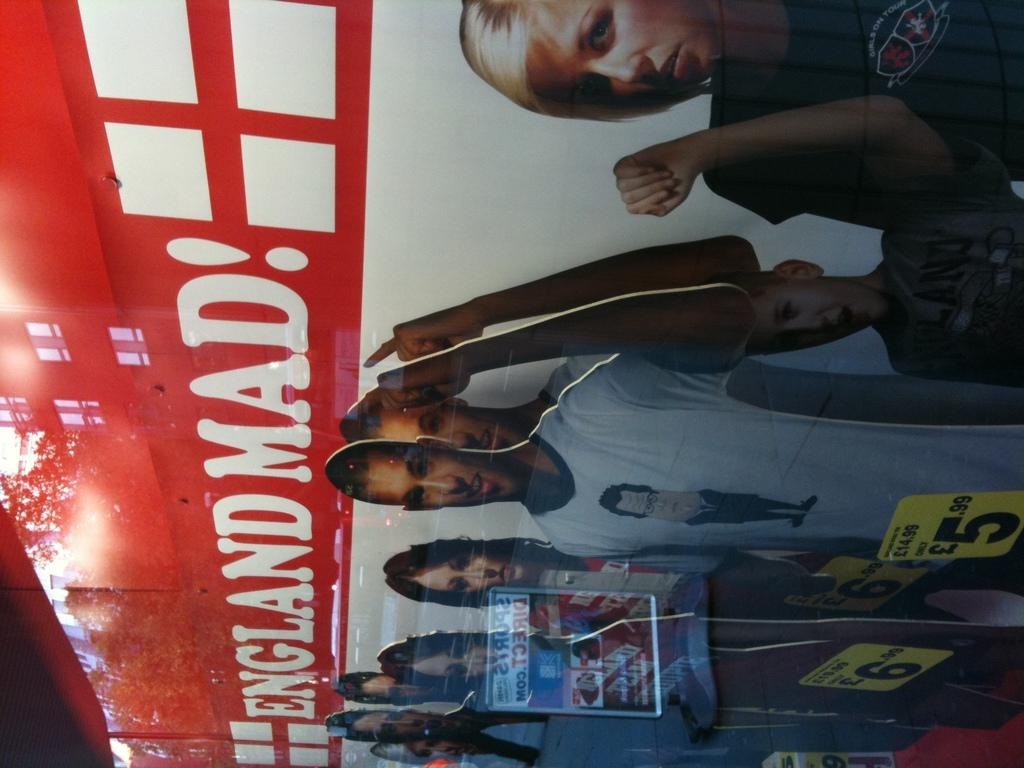What types of people are depicted on the banner? There are girls and boys on the banner. Can you describe the gender representation on the banner? The banner features both girls and boys. What type of lock can be seen securing the banner in the image? There is no lock present in the image; it features a banner with girls and boys. What type of truck is visible transporting the banner in the image? There is no truck present in the image; it features a banner with girls and boys. 